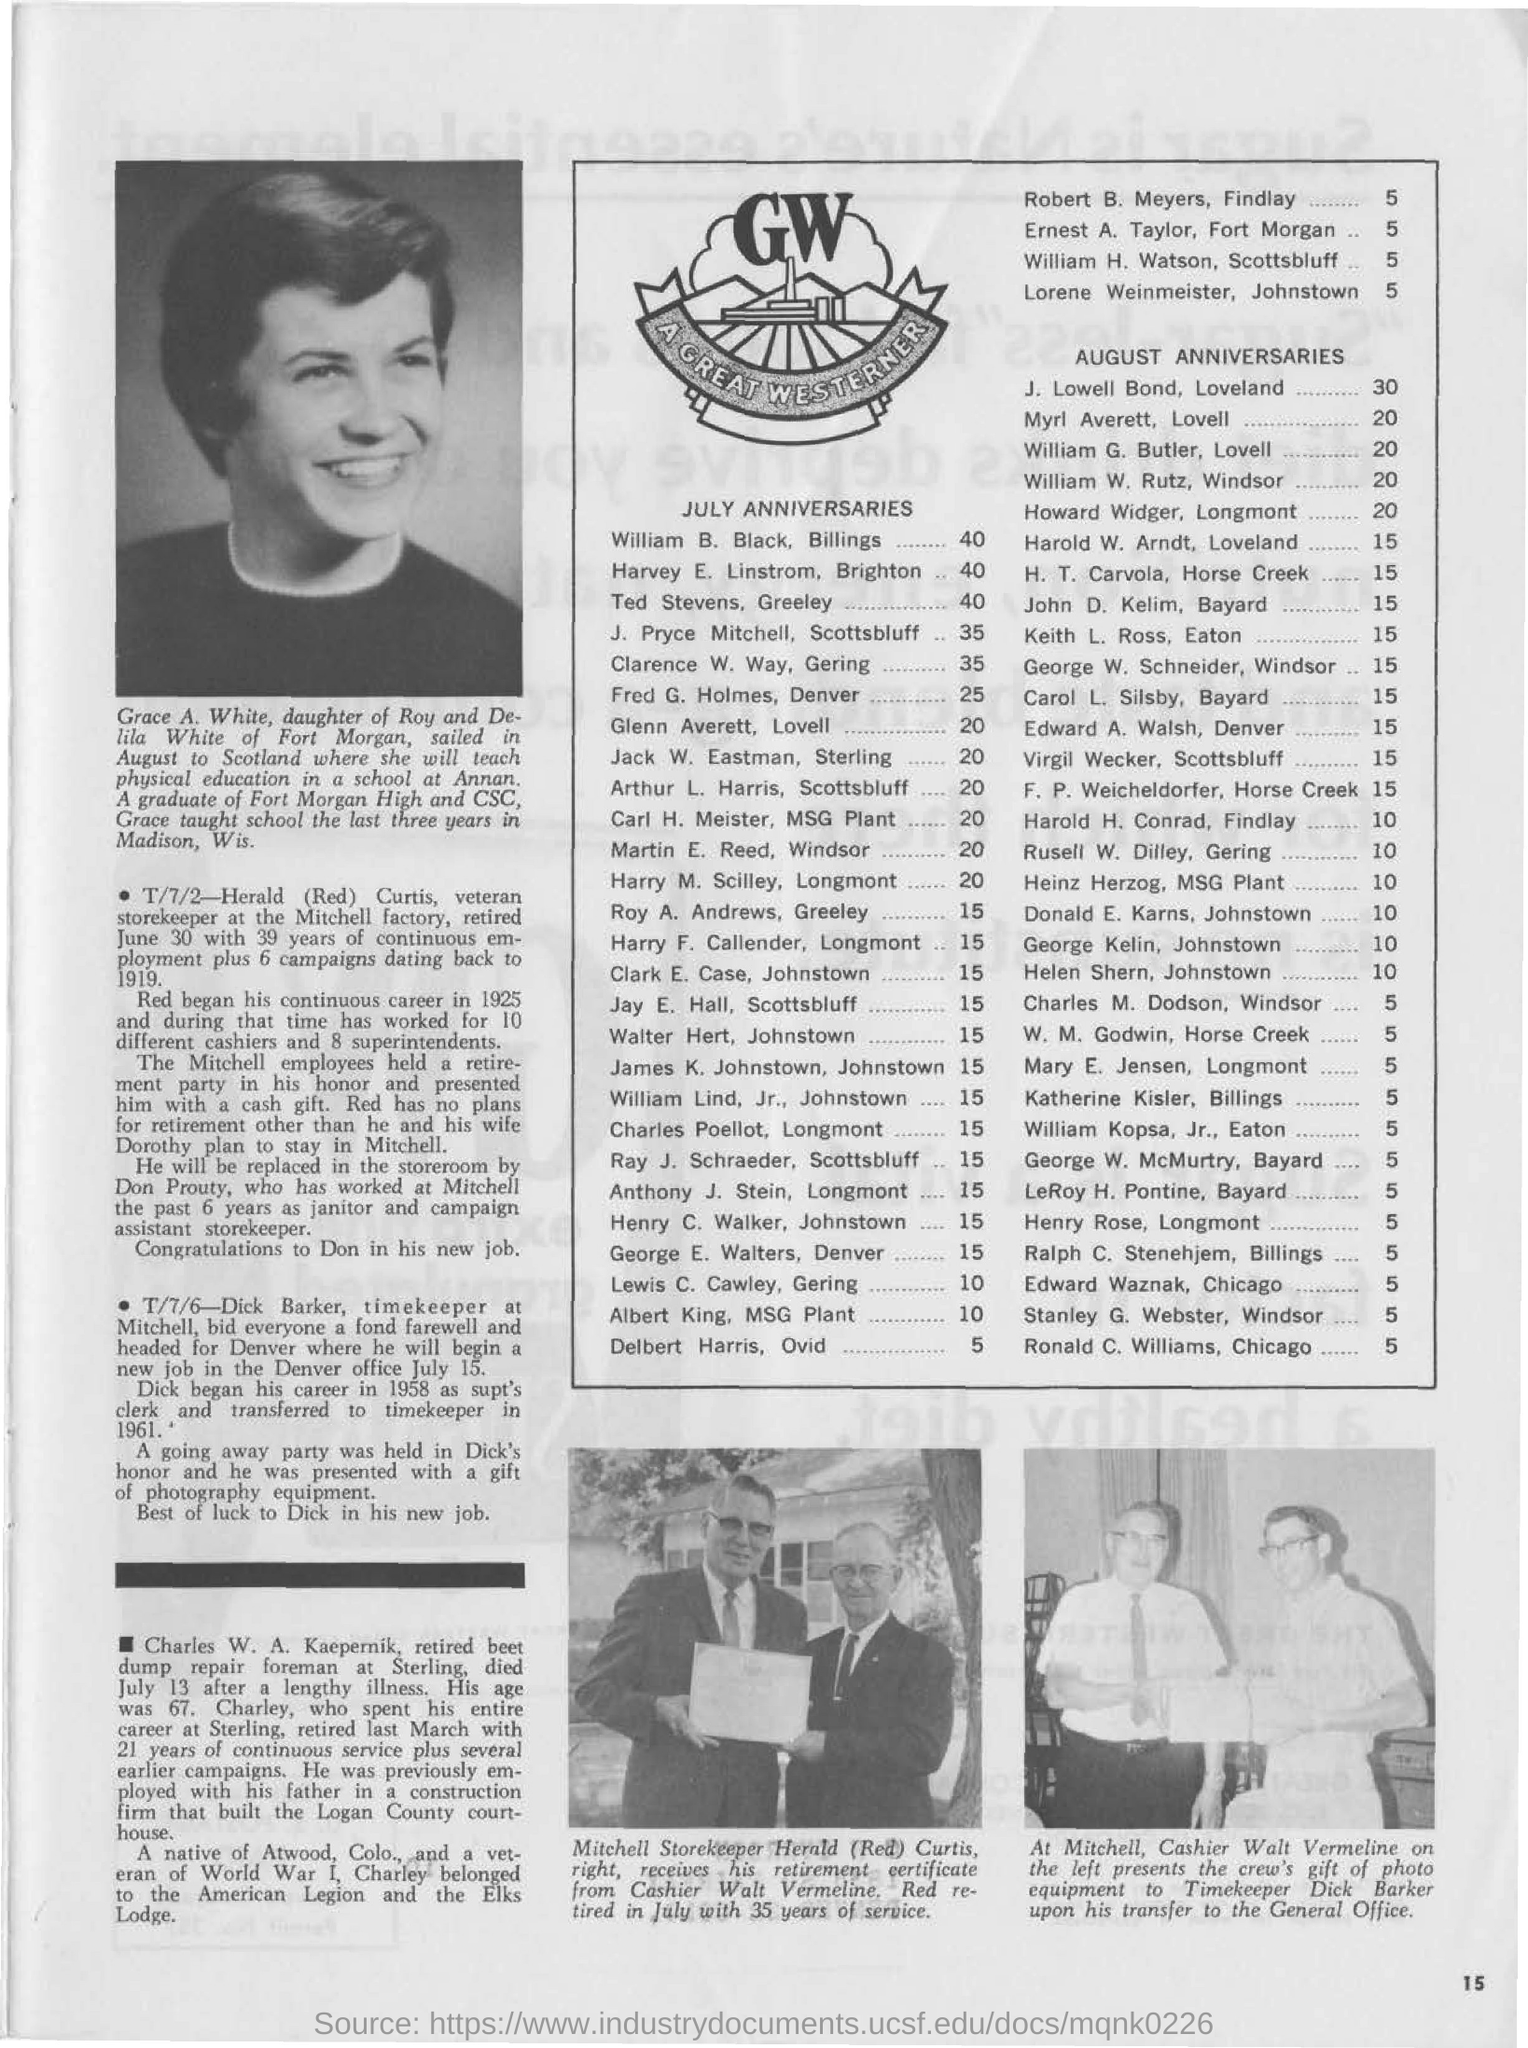When is j. lowell bond's anniversary?
Provide a short and direct response. AUGUST. Which month is myry averett's anniversary?
Your response must be concise. AUGUST. Which month is j. pryce mitchell's anniversary?
Ensure brevity in your answer.  July. 